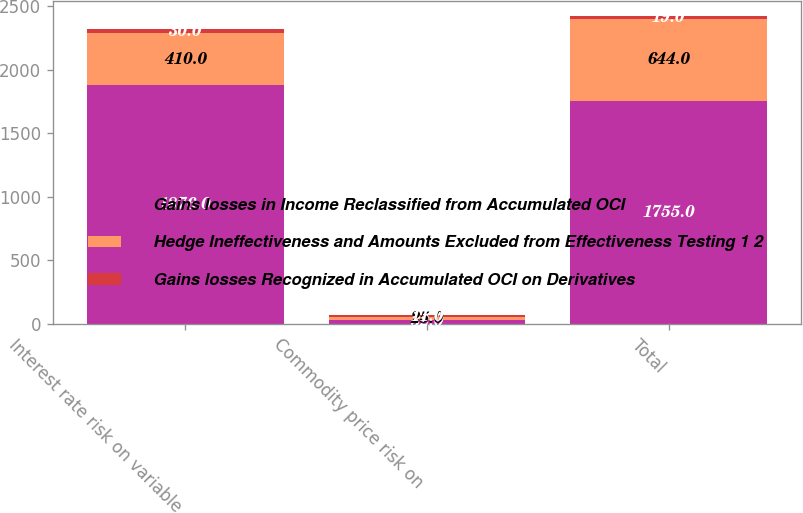Convert chart to OTSL. <chart><loc_0><loc_0><loc_500><loc_500><stacked_bar_chart><ecel><fcel>Interest rate risk on variable<fcel>Commodity price risk on<fcel>Total<nl><fcel>Gains losses in Income Reclassified from Accumulated OCI<fcel>1876<fcel>32<fcel>1755<nl><fcel>Hedge Ineffectiveness and Amounts Excluded from Effectiveness Testing 1 2<fcel>410<fcel>25<fcel>644<nl><fcel>Gains losses Recognized in Accumulated OCI on Derivatives<fcel>30<fcel>11<fcel>19<nl></chart> 